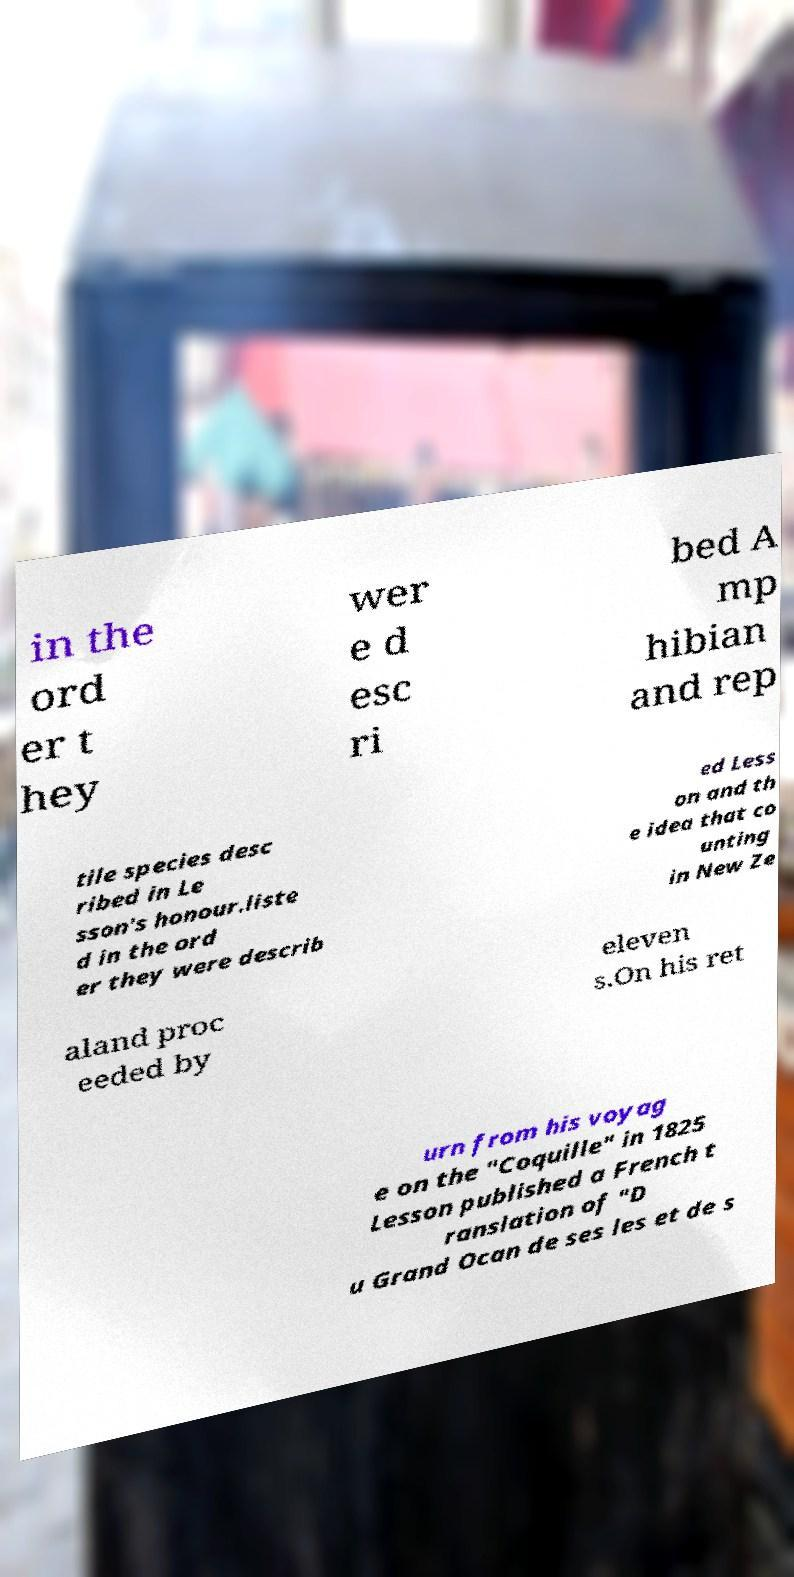There's text embedded in this image that I need extracted. Can you transcribe it verbatim? in the ord er t hey wer e d esc ri bed A mp hibian and rep tile species desc ribed in Le sson's honour.liste d in the ord er they were describ ed Less on and th e idea that co unting in New Ze aland proc eeded by eleven s.On his ret urn from his voyag e on the "Coquille" in 1825 Lesson published a French t ranslation of "D u Grand Ocan de ses les et de s 